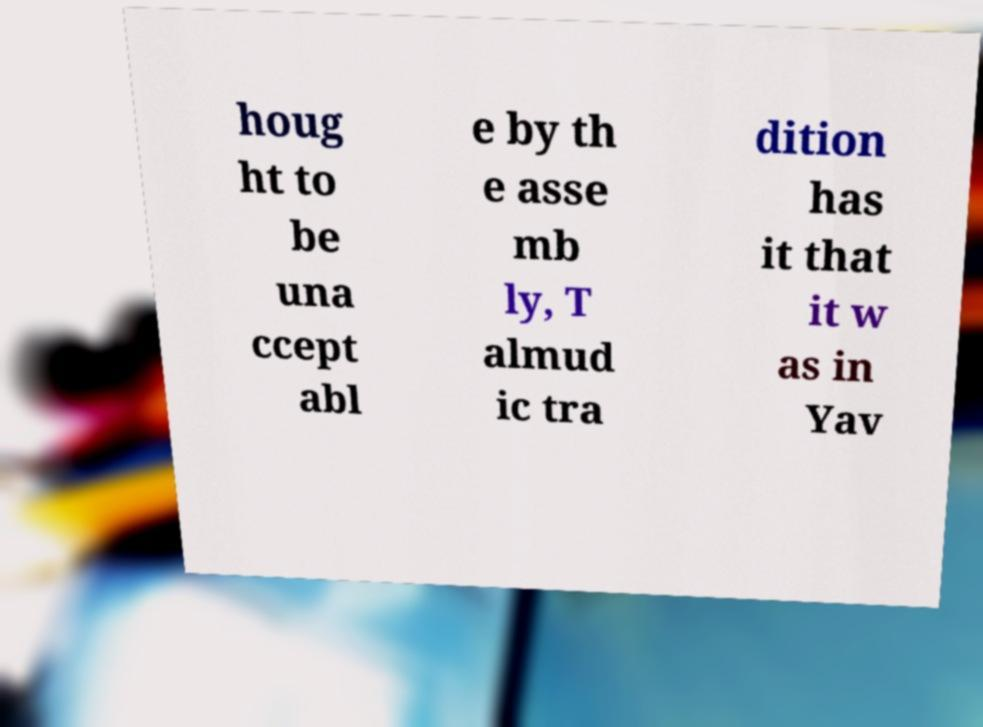I need the written content from this picture converted into text. Can you do that? houg ht to be una ccept abl e by th e asse mb ly, T almud ic tra dition has it that it w as in Yav 